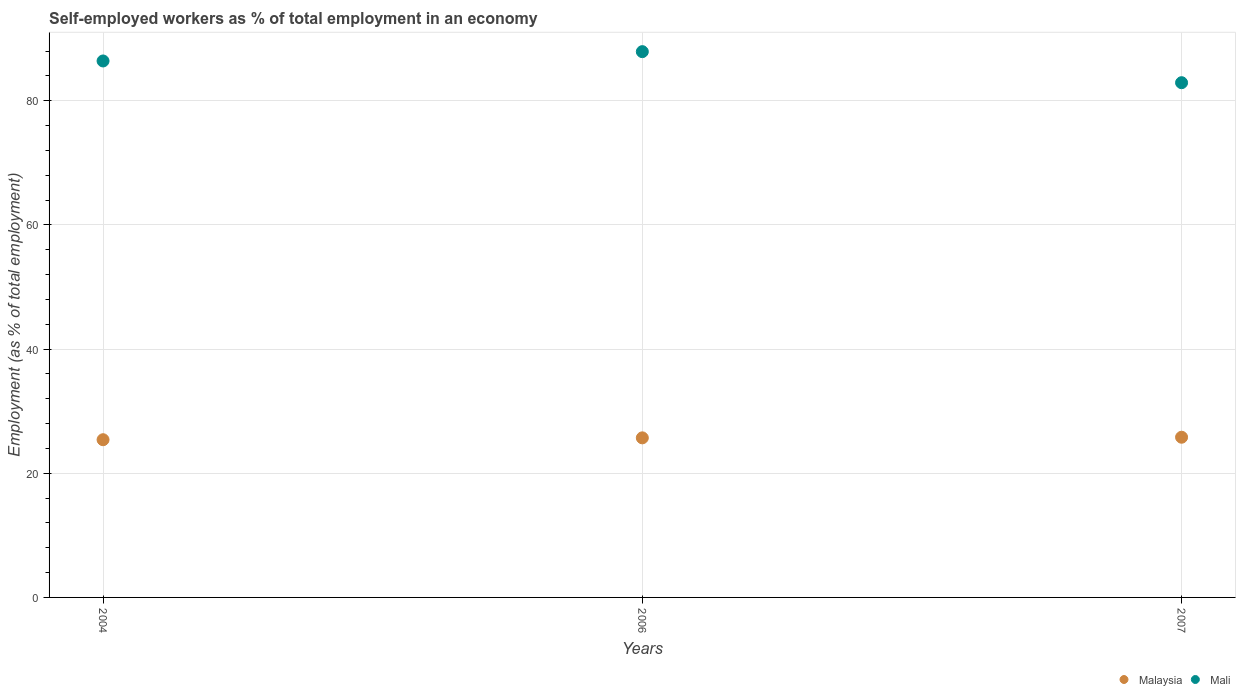How many different coloured dotlines are there?
Your answer should be very brief. 2. What is the percentage of self-employed workers in Malaysia in 2007?
Ensure brevity in your answer.  25.8. Across all years, what is the maximum percentage of self-employed workers in Malaysia?
Make the answer very short. 25.8. Across all years, what is the minimum percentage of self-employed workers in Malaysia?
Ensure brevity in your answer.  25.4. In which year was the percentage of self-employed workers in Malaysia maximum?
Ensure brevity in your answer.  2007. What is the total percentage of self-employed workers in Mali in the graph?
Your response must be concise. 257.2. What is the difference between the percentage of self-employed workers in Malaysia in 2006 and that in 2007?
Offer a very short reply. -0.1. What is the difference between the percentage of self-employed workers in Mali in 2006 and the percentage of self-employed workers in Malaysia in 2004?
Keep it short and to the point. 62.5. What is the average percentage of self-employed workers in Mali per year?
Keep it short and to the point. 85.73. In the year 2007, what is the difference between the percentage of self-employed workers in Mali and percentage of self-employed workers in Malaysia?
Offer a terse response. 57.1. In how many years, is the percentage of self-employed workers in Malaysia greater than 12 %?
Your response must be concise. 3. What is the ratio of the percentage of self-employed workers in Mali in 2004 to that in 2006?
Make the answer very short. 0.98. What is the difference between the highest and the second highest percentage of self-employed workers in Malaysia?
Your answer should be very brief. 0.1. In how many years, is the percentage of self-employed workers in Mali greater than the average percentage of self-employed workers in Mali taken over all years?
Make the answer very short. 2. Does the percentage of self-employed workers in Mali monotonically increase over the years?
Make the answer very short. No. Is the percentage of self-employed workers in Mali strictly greater than the percentage of self-employed workers in Malaysia over the years?
Give a very brief answer. Yes. Is the percentage of self-employed workers in Mali strictly less than the percentage of self-employed workers in Malaysia over the years?
Offer a terse response. No. How many dotlines are there?
Provide a short and direct response. 2. How many years are there in the graph?
Give a very brief answer. 3. What is the difference between two consecutive major ticks on the Y-axis?
Offer a very short reply. 20. Are the values on the major ticks of Y-axis written in scientific E-notation?
Keep it short and to the point. No. Does the graph contain grids?
Your response must be concise. Yes. How many legend labels are there?
Provide a short and direct response. 2. How are the legend labels stacked?
Keep it short and to the point. Horizontal. What is the title of the graph?
Ensure brevity in your answer.  Self-employed workers as % of total employment in an economy. Does "Kyrgyz Republic" appear as one of the legend labels in the graph?
Offer a terse response. No. What is the label or title of the Y-axis?
Offer a very short reply. Employment (as % of total employment). What is the Employment (as % of total employment) of Malaysia in 2004?
Provide a succinct answer. 25.4. What is the Employment (as % of total employment) in Mali in 2004?
Give a very brief answer. 86.4. What is the Employment (as % of total employment) of Malaysia in 2006?
Provide a short and direct response. 25.7. What is the Employment (as % of total employment) in Mali in 2006?
Offer a very short reply. 87.9. What is the Employment (as % of total employment) in Malaysia in 2007?
Give a very brief answer. 25.8. What is the Employment (as % of total employment) in Mali in 2007?
Provide a succinct answer. 82.9. Across all years, what is the maximum Employment (as % of total employment) of Malaysia?
Your answer should be very brief. 25.8. Across all years, what is the maximum Employment (as % of total employment) of Mali?
Keep it short and to the point. 87.9. Across all years, what is the minimum Employment (as % of total employment) of Malaysia?
Your response must be concise. 25.4. Across all years, what is the minimum Employment (as % of total employment) in Mali?
Ensure brevity in your answer.  82.9. What is the total Employment (as % of total employment) in Malaysia in the graph?
Provide a short and direct response. 76.9. What is the total Employment (as % of total employment) of Mali in the graph?
Give a very brief answer. 257.2. What is the difference between the Employment (as % of total employment) in Mali in 2004 and that in 2006?
Offer a terse response. -1.5. What is the difference between the Employment (as % of total employment) in Malaysia in 2006 and that in 2007?
Provide a short and direct response. -0.1. What is the difference between the Employment (as % of total employment) in Mali in 2006 and that in 2007?
Ensure brevity in your answer.  5. What is the difference between the Employment (as % of total employment) of Malaysia in 2004 and the Employment (as % of total employment) of Mali in 2006?
Offer a very short reply. -62.5. What is the difference between the Employment (as % of total employment) of Malaysia in 2004 and the Employment (as % of total employment) of Mali in 2007?
Your answer should be very brief. -57.5. What is the difference between the Employment (as % of total employment) of Malaysia in 2006 and the Employment (as % of total employment) of Mali in 2007?
Your answer should be very brief. -57.2. What is the average Employment (as % of total employment) of Malaysia per year?
Offer a very short reply. 25.63. What is the average Employment (as % of total employment) in Mali per year?
Give a very brief answer. 85.73. In the year 2004, what is the difference between the Employment (as % of total employment) in Malaysia and Employment (as % of total employment) in Mali?
Offer a very short reply. -61. In the year 2006, what is the difference between the Employment (as % of total employment) of Malaysia and Employment (as % of total employment) of Mali?
Offer a very short reply. -62.2. In the year 2007, what is the difference between the Employment (as % of total employment) of Malaysia and Employment (as % of total employment) of Mali?
Your answer should be compact. -57.1. What is the ratio of the Employment (as % of total employment) of Malaysia in 2004 to that in 2006?
Offer a very short reply. 0.99. What is the ratio of the Employment (as % of total employment) of Mali in 2004 to that in 2006?
Give a very brief answer. 0.98. What is the ratio of the Employment (as % of total employment) of Malaysia in 2004 to that in 2007?
Offer a very short reply. 0.98. What is the ratio of the Employment (as % of total employment) of Mali in 2004 to that in 2007?
Make the answer very short. 1.04. What is the ratio of the Employment (as % of total employment) of Malaysia in 2006 to that in 2007?
Ensure brevity in your answer.  1. What is the ratio of the Employment (as % of total employment) in Mali in 2006 to that in 2007?
Your answer should be very brief. 1.06. What is the difference between the highest and the second highest Employment (as % of total employment) in Malaysia?
Your answer should be compact. 0.1. What is the difference between the highest and the lowest Employment (as % of total employment) of Malaysia?
Make the answer very short. 0.4. What is the difference between the highest and the lowest Employment (as % of total employment) of Mali?
Offer a very short reply. 5. 